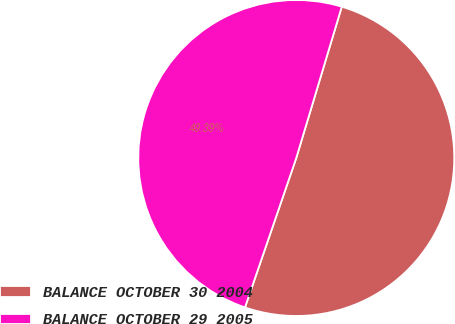<chart> <loc_0><loc_0><loc_500><loc_500><pie_chart><fcel>BALANCE OCTOBER 30 2004<fcel>BALANCE OCTOBER 29 2005<nl><fcel>50.61%<fcel>49.39%<nl></chart> 